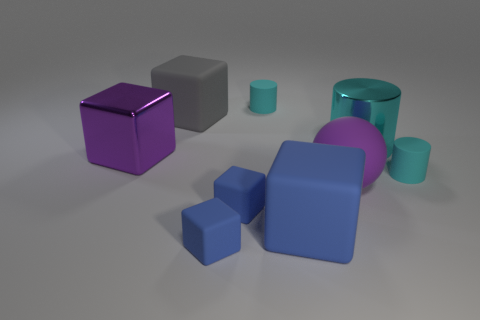Add 1 tiny matte cylinders. How many objects exist? 10 Subtract all gray matte cubes. How many cubes are left? 4 Subtract 1 cylinders. How many cylinders are left? 2 Subtract all gray cubes. How many cubes are left? 4 Add 1 tiny matte objects. How many tiny matte objects exist? 5 Subtract 0 gray spheres. How many objects are left? 9 Subtract all spheres. How many objects are left? 8 Subtract all yellow cubes. Subtract all brown balls. How many cubes are left? 5 Subtract all purple cubes. How many green cylinders are left? 0 Subtract all large purple matte balls. Subtract all cylinders. How many objects are left? 5 